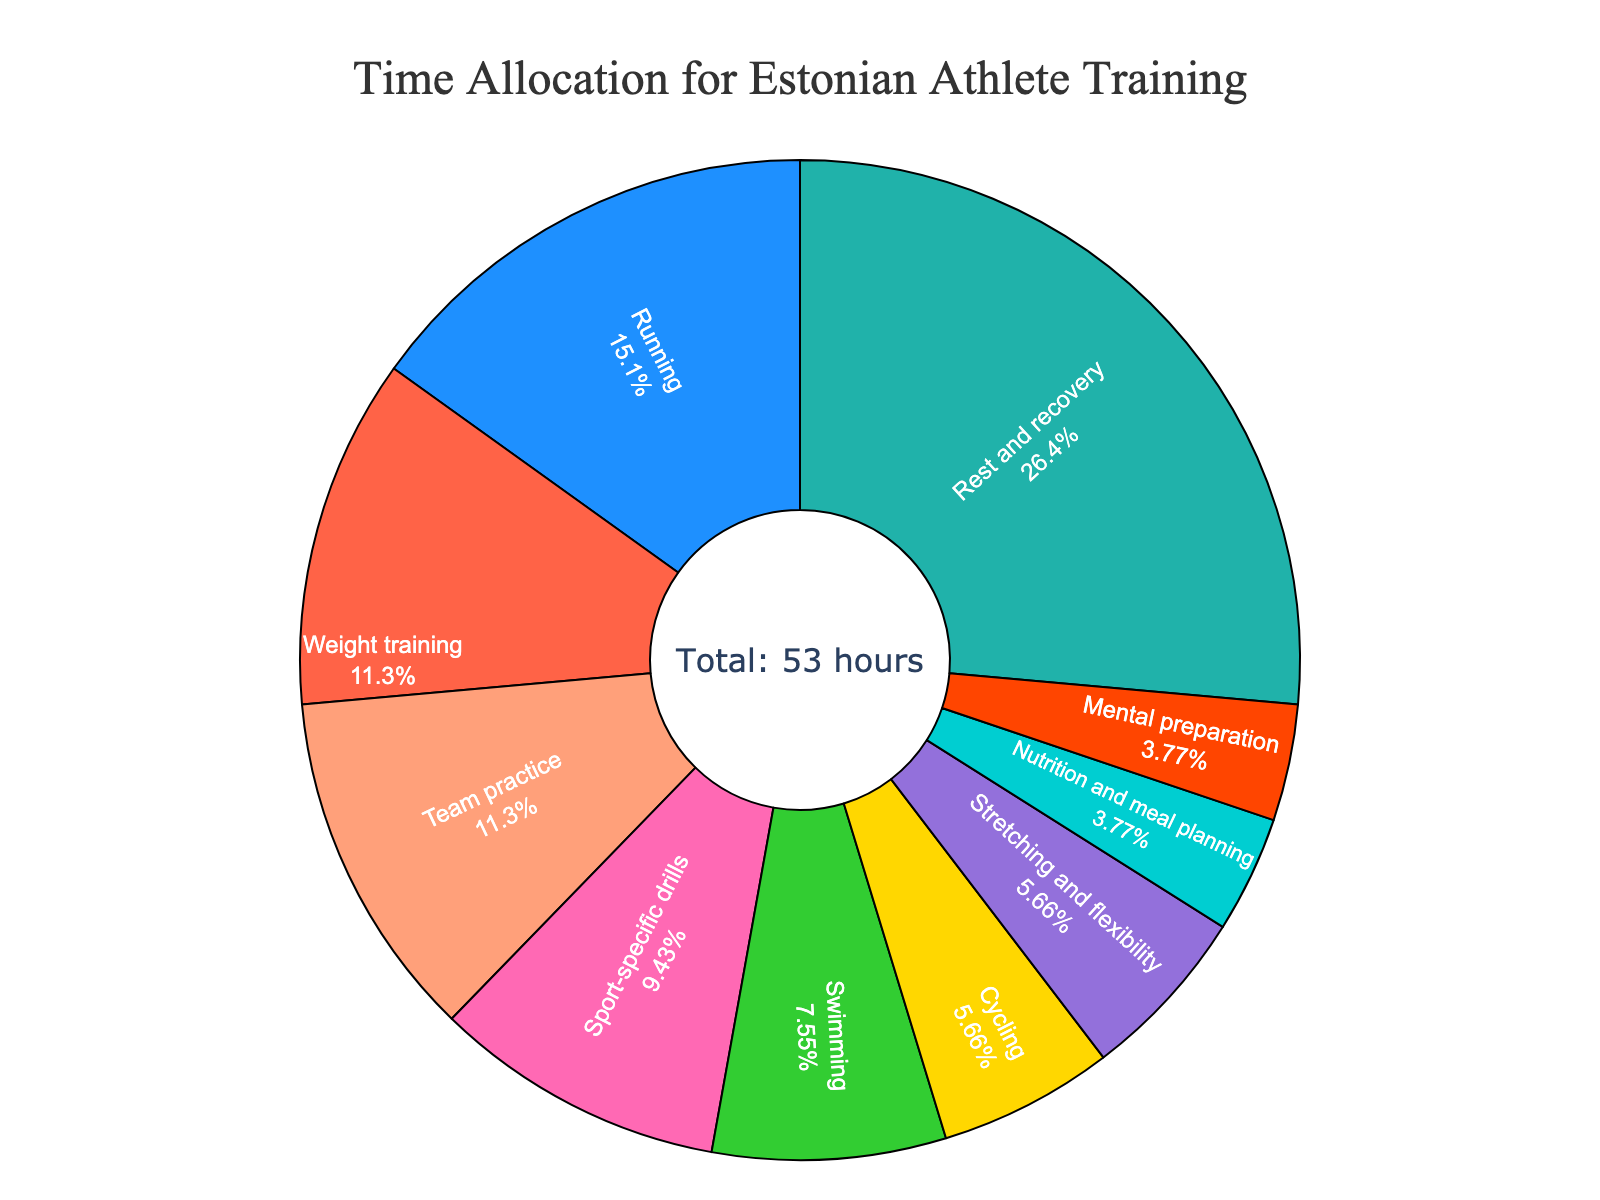How many total hours per week are dedicated to team practice and sport-specific drills combined? Team practice takes 6 hours per week and sport-specific drills take 5 hours per week. Combined, this equals 6 + 5 = 11 hours.
Answer: 11 Which activity takes up the largest portion of the weekly training time, and approximately what percentage of the total does it represent? The activity with the largest portion is rest and recovery, which represents 14 hours per week. Since there is a total of 53 hours, the percentage can be calculated as (14 / 53) * 100 ≈ 26.4%.
Answer: Rest and recovery, ≈ 26.4% How many hours are dedicated to activities other than rest and recovery per week? The total hours per week is 53. Subtracting rest and recovery, which is 14 hours, yields 53 - 14 = 39 hours for other activities.
Answer: 39 Is there any activity that accounts for exactly 11.3% of the total training time? If so, which one? For an activity to account for 11.3% of the total time, it needs to correspond to (0.113 * 53) ≈ 6 hours. Weight training and team practice are 6 hours each, matching this percentage.
Answer: Weight training and team practice Which activity has fewer hours allocated per week: swimming or cycling? According to the data, swimming has 4 hours allocated per week, whereas cycling has 3 hours. Therefore, cycling has fewer hours allocated.
Answer: Cycling What is the combined percentage of time spent on running, weight training, and swimming? Hours spent are: running (8), weight training (6), and swimming (4). Total hours is 8 + 6 + 4 = 18. The percentage is (18 / 53) * 100 ≈ 34.0%.
Answer: ≈ 34.0% Which activity occupies a larger portion of the pie chart: nutrition and meal planning or mental preparation? Both nutrition and meal planning and mental preparation have the same amount of hours dedicated, which is 2 hours each. Hence, both occupy the same portion of the pie chart.
Answer: Both are the same Among running, cycling, and stretching and flexibility, which activity takes the second most time per week? Running takes 8 hours per week, cycling takes 3 hours, and stretching and flexibility takes 3 hours. Therefore, stretching and flexibility, as well as cycling, with both at 3 hours, tie for the second most time after running.
Answer: Stretching and flexibility, and cycling (tied) How does the time allocation for team practice compare with mental preparation? Team practice has 6 hours per week compared to mental preparation, which has 2 hours per week. Therefore, team practice has 4 hours more than mental preparation.
Answer: Team practice has 4 hours more 